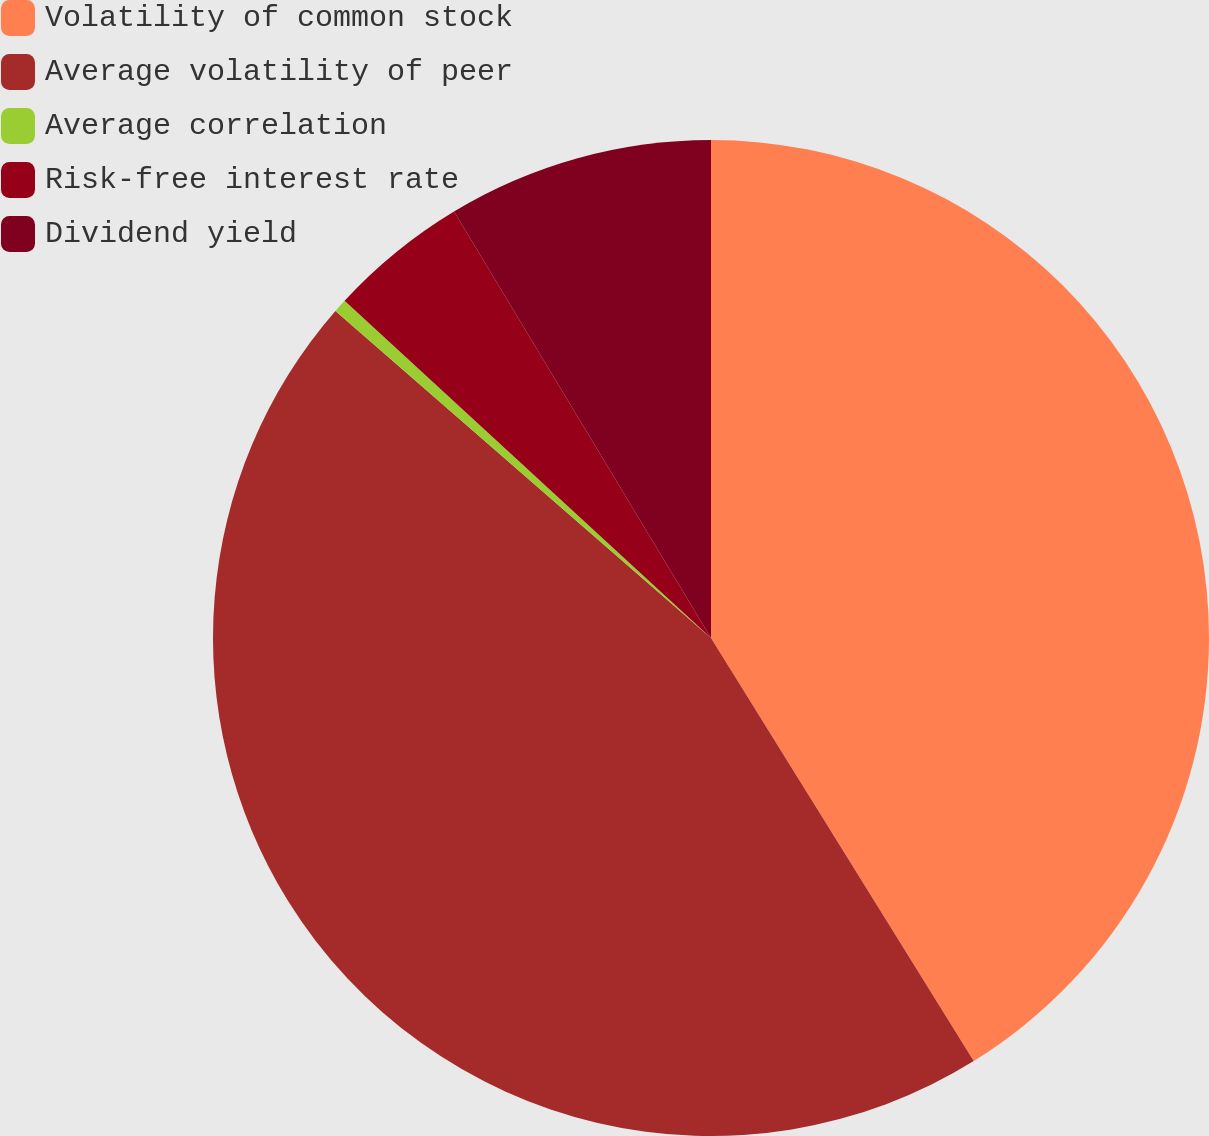<chart> <loc_0><loc_0><loc_500><loc_500><pie_chart><fcel>Volatility of common stock<fcel>Average volatility of peer<fcel>Average correlation<fcel>Risk-free interest rate<fcel>Dividend yield<nl><fcel>41.16%<fcel>45.25%<fcel>0.44%<fcel>4.53%<fcel>8.63%<nl></chart> 